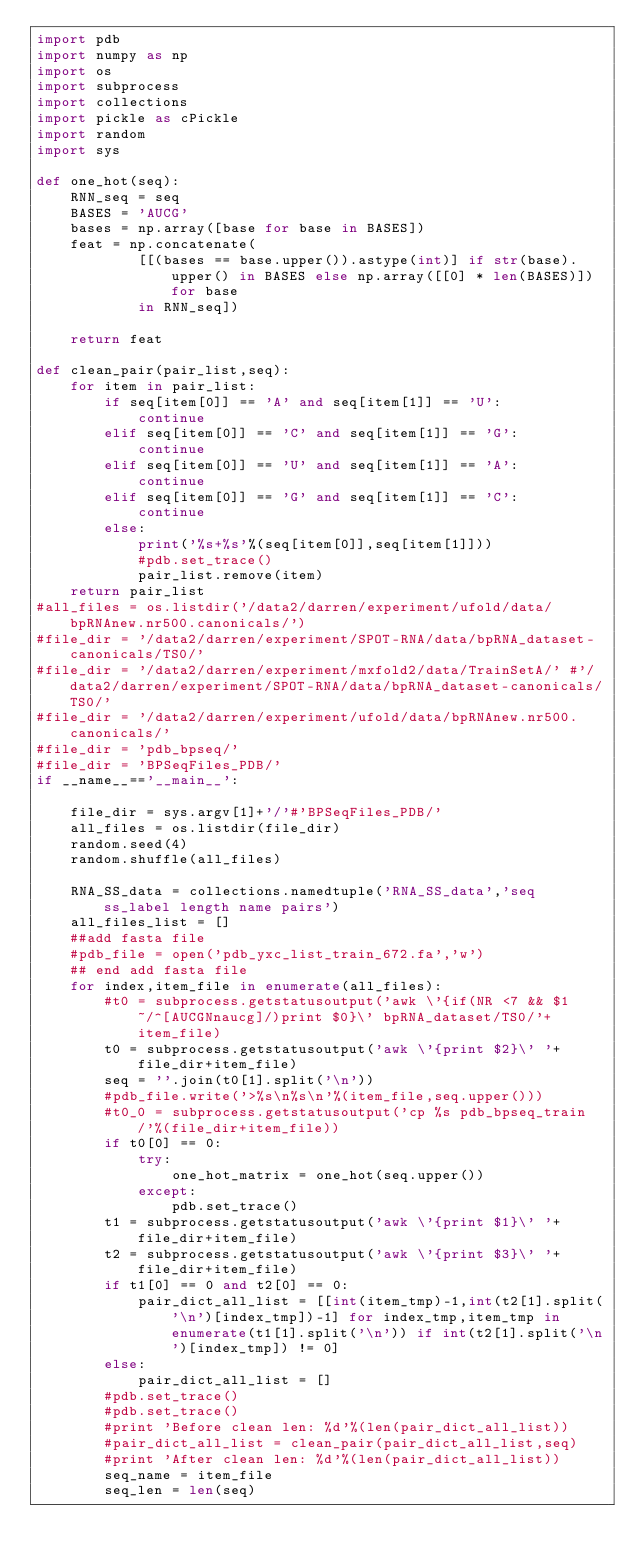<code> <loc_0><loc_0><loc_500><loc_500><_Python_>import pdb
import numpy as np
import os
import subprocess
import collections
import pickle as cPickle
import random
import sys

def one_hot(seq):
    RNN_seq = seq
    BASES = 'AUCG'
    bases = np.array([base for base in BASES])
    feat = np.concatenate(
            [[(bases == base.upper()).astype(int)] if str(base).upper() in BASES else np.array([[0] * len(BASES)]) for base
            in RNN_seq])

    return feat

def clean_pair(pair_list,seq):
    for item in pair_list:
        if seq[item[0]] == 'A' and seq[item[1]] == 'U':
            continue
        elif seq[item[0]] == 'C' and seq[item[1]] == 'G':
            continue
        elif seq[item[0]] == 'U' and seq[item[1]] == 'A':
            continue
        elif seq[item[0]] == 'G' and seq[item[1]] == 'C':
            continue
        else:
            print('%s+%s'%(seq[item[0]],seq[item[1]]))
            #pdb.set_trace()
            pair_list.remove(item)
    return pair_list
#all_files = os.listdir('/data2/darren/experiment/ufold/data/bpRNAnew.nr500.canonicals/')
#file_dir = '/data2/darren/experiment/SPOT-RNA/data/bpRNA_dataset-canonicals/TS0/'
#file_dir = '/data2/darren/experiment/mxfold2/data/TrainSetA/' #'/data2/darren/experiment/SPOT-RNA/data/bpRNA_dataset-canonicals/TS0/'
#file_dir = '/data2/darren/experiment/ufold/data/bpRNAnew.nr500.canonicals/'
#file_dir = 'pdb_bpseq/'
#file_dir = 'BPSeqFiles_PDB/'
if __name__=='__main__':

    file_dir = sys.argv[1]+'/'#'BPSeqFiles_PDB/'
    all_files = os.listdir(file_dir)
    random.seed(4)
    random.shuffle(all_files)
    
    RNA_SS_data = collections.namedtuple('RNA_SS_data','seq ss_label length name pairs')
    all_files_list = []
    ##add fasta file
    #pdb_file = open('pdb_yxc_list_train_672.fa','w')
    ## end add fasta file
    for index,item_file in enumerate(all_files):
        #t0 = subprocess.getstatusoutput('awk \'{if(NR <7 && $1 ~/^[AUCGNnaucg]/)print $0}\' bpRNA_dataset/TS0/'+item_file)
        t0 = subprocess.getstatusoutput('awk \'{print $2}\' '+file_dir+item_file)
        seq = ''.join(t0[1].split('\n'))
        #pdb_file.write('>%s\n%s\n'%(item_file,seq.upper()))
        #t0_0 = subprocess.getstatusoutput('cp %s pdb_bpseq_train/'%(file_dir+item_file))
        if t0[0] == 0:
            try:
                one_hot_matrix = one_hot(seq.upper())
            except:
                pdb.set_trace()
        t1 = subprocess.getstatusoutput('awk \'{print $1}\' '+file_dir+item_file)
        t2 = subprocess.getstatusoutput('awk \'{print $3}\' '+file_dir+item_file)
        if t1[0] == 0 and t2[0] == 0:
            pair_dict_all_list = [[int(item_tmp)-1,int(t2[1].split('\n')[index_tmp])-1] for index_tmp,item_tmp in enumerate(t1[1].split('\n')) if int(t2[1].split('\n')[index_tmp]) != 0]
        else:
            pair_dict_all_list = []
        #pdb.set_trace()
        #pdb.set_trace()
        #print 'Before clean len: %d'%(len(pair_dict_all_list))
        #pair_dict_all_list = clean_pair(pair_dict_all_list,seq)
        #print 'After clean len: %d'%(len(pair_dict_all_list))
        seq_name = item_file
        seq_len = len(seq)</code> 